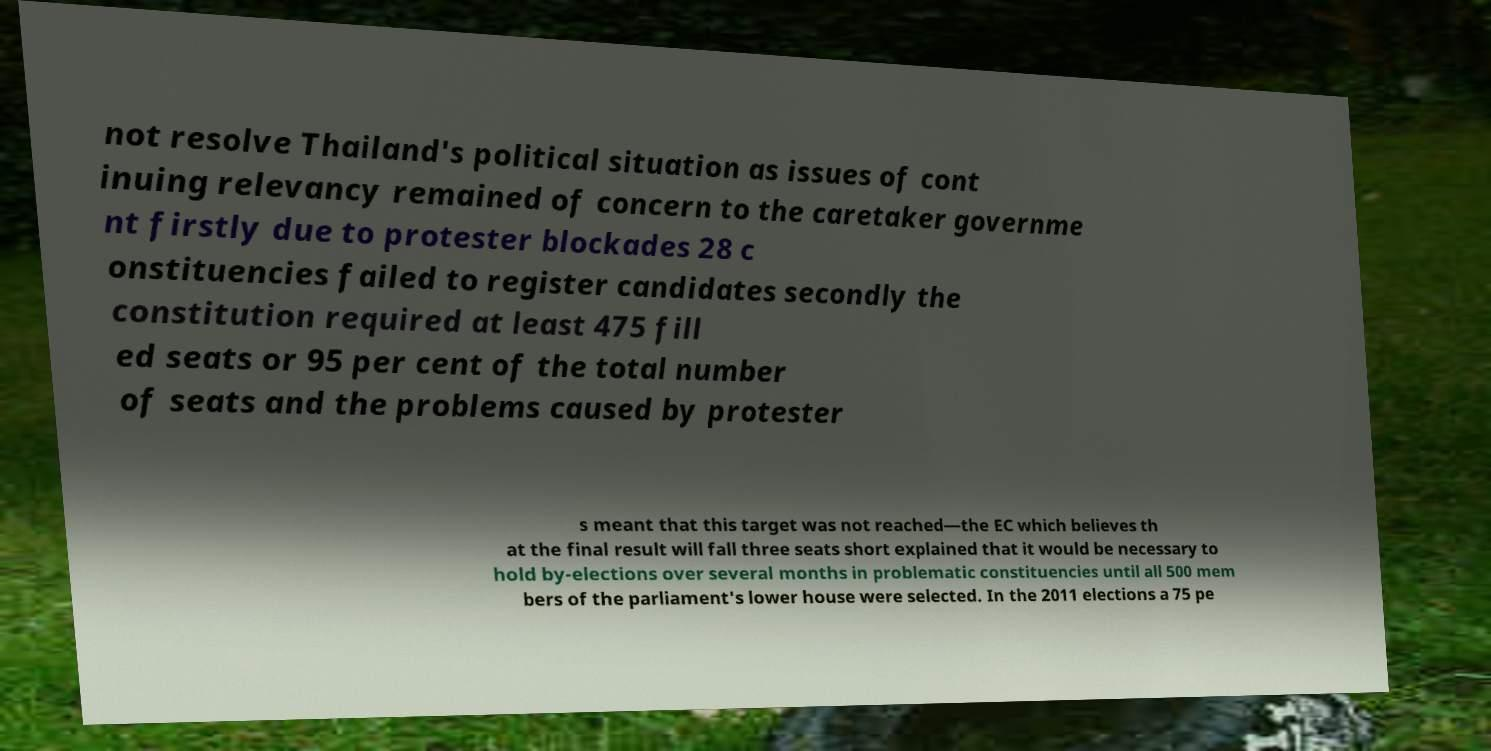I need the written content from this picture converted into text. Can you do that? not resolve Thailand's political situation as issues of cont inuing relevancy remained of concern to the caretaker governme nt firstly due to protester blockades 28 c onstituencies failed to register candidates secondly the constitution required at least 475 fill ed seats or 95 per cent of the total number of seats and the problems caused by protester s meant that this target was not reached—the EC which believes th at the final result will fall three seats short explained that it would be necessary to hold by-elections over several months in problematic constituencies until all 500 mem bers of the parliament's lower house were selected. In the 2011 elections a 75 pe 